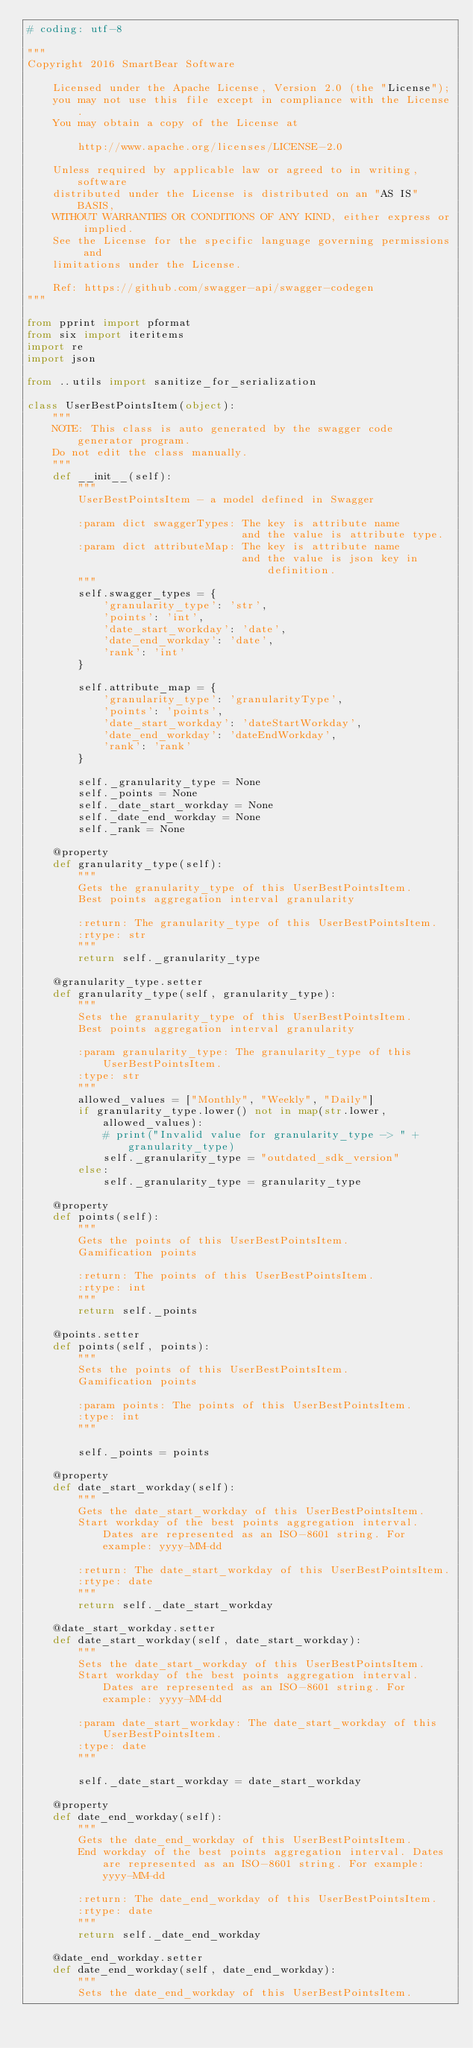Convert code to text. <code><loc_0><loc_0><loc_500><loc_500><_Python_># coding: utf-8

"""
Copyright 2016 SmartBear Software

    Licensed under the Apache License, Version 2.0 (the "License");
    you may not use this file except in compliance with the License.
    You may obtain a copy of the License at

        http://www.apache.org/licenses/LICENSE-2.0

    Unless required by applicable law or agreed to in writing, software
    distributed under the License is distributed on an "AS IS" BASIS,
    WITHOUT WARRANTIES OR CONDITIONS OF ANY KIND, either express or implied.
    See the License for the specific language governing permissions and
    limitations under the License.

    Ref: https://github.com/swagger-api/swagger-codegen
"""

from pprint import pformat
from six import iteritems
import re
import json

from ..utils import sanitize_for_serialization

class UserBestPointsItem(object):
    """
    NOTE: This class is auto generated by the swagger code generator program.
    Do not edit the class manually.
    """
    def __init__(self):
        """
        UserBestPointsItem - a model defined in Swagger

        :param dict swaggerTypes: The key is attribute name
                                  and the value is attribute type.
        :param dict attributeMap: The key is attribute name
                                  and the value is json key in definition.
        """
        self.swagger_types = {
            'granularity_type': 'str',
            'points': 'int',
            'date_start_workday': 'date',
            'date_end_workday': 'date',
            'rank': 'int'
        }

        self.attribute_map = {
            'granularity_type': 'granularityType',
            'points': 'points',
            'date_start_workday': 'dateStartWorkday',
            'date_end_workday': 'dateEndWorkday',
            'rank': 'rank'
        }

        self._granularity_type = None
        self._points = None
        self._date_start_workday = None
        self._date_end_workday = None
        self._rank = None

    @property
    def granularity_type(self):
        """
        Gets the granularity_type of this UserBestPointsItem.
        Best points aggregation interval granularity

        :return: The granularity_type of this UserBestPointsItem.
        :rtype: str
        """
        return self._granularity_type

    @granularity_type.setter
    def granularity_type(self, granularity_type):
        """
        Sets the granularity_type of this UserBestPointsItem.
        Best points aggregation interval granularity

        :param granularity_type: The granularity_type of this UserBestPointsItem.
        :type: str
        """
        allowed_values = ["Monthly", "Weekly", "Daily"]
        if granularity_type.lower() not in map(str.lower, allowed_values):
            # print("Invalid value for granularity_type -> " + granularity_type)
            self._granularity_type = "outdated_sdk_version"
        else:
            self._granularity_type = granularity_type

    @property
    def points(self):
        """
        Gets the points of this UserBestPointsItem.
        Gamification points

        :return: The points of this UserBestPointsItem.
        :rtype: int
        """
        return self._points

    @points.setter
    def points(self, points):
        """
        Sets the points of this UserBestPointsItem.
        Gamification points

        :param points: The points of this UserBestPointsItem.
        :type: int
        """
        
        self._points = points

    @property
    def date_start_workday(self):
        """
        Gets the date_start_workday of this UserBestPointsItem.
        Start workday of the best points aggregation interval. Dates are represented as an ISO-8601 string. For example: yyyy-MM-dd

        :return: The date_start_workday of this UserBestPointsItem.
        :rtype: date
        """
        return self._date_start_workday

    @date_start_workday.setter
    def date_start_workday(self, date_start_workday):
        """
        Sets the date_start_workday of this UserBestPointsItem.
        Start workday of the best points aggregation interval. Dates are represented as an ISO-8601 string. For example: yyyy-MM-dd

        :param date_start_workday: The date_start_workday of this UserBestPointsItem.
        :type: date
        """
        
        self._date_start_workday = date_start_workday

    @property
    def date_end_workday(self):
        """
        Gets the date_end_workday of this UserBestPointsItem.
        End workday of the best points aggregation interval. Dates are represented as an ISO-8601 string. For example: yyyy-MM-dd

        :return: The date_end_workday of this UserBestPointsItem.
        :rtype: date
        """
        return self._date_end_workday

    @date_end_workday.setter
    def date_end_workday(self, date_end_workday):
        """
        Sets the date_end_workday of this UserBestPointsItem.</code> 